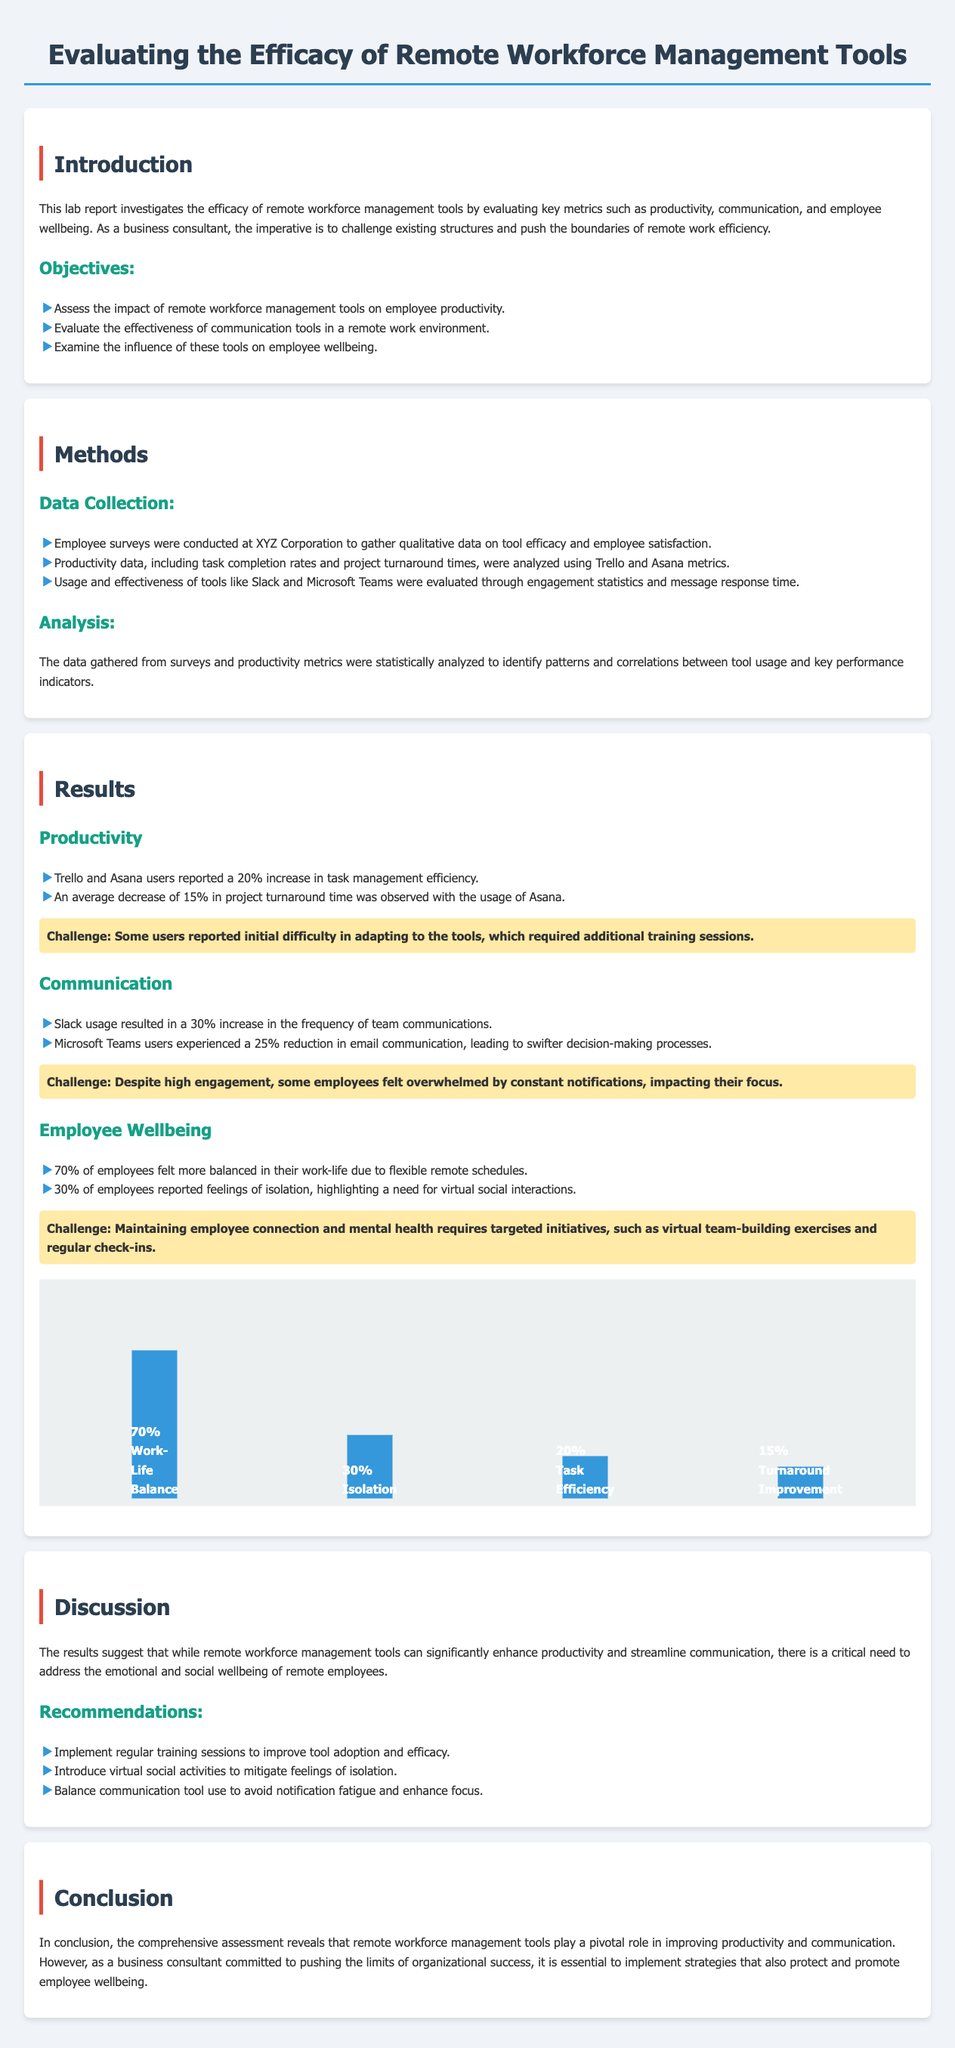what was the increase in task management efficiency reported by Trello and Asana users? The document states that Trello and Asana users reported a 20% increase in task management efficiency.
Answer: 20% what percentage of employees felt more balanced in their work-life? According to the results, 70% of employees felt more balanced in their work-life due to flexible remote schedules.
Answer: 70% which tool resulted in a 30% increase in the frequency of team communications? The results indicate that Slack usage led to a 30% increase in the frequency of team communications.
Answer: Slack what percentage of employees reported feelings of isolation? The document mentions that 30% of employees reported feelings of isolation.
Answer: 30% what is one of the key recommendations for improving tool efficacy? The report recommends implementing regular training sessions to improve tool adoption and efficacy.
Answer: Regular training sessions what was the average decrease in project turnaround time with Asana? The document notes an average decrease of 15% in project turnaround time observed with the usage of Asana.
Answer: 15% how many employees responded positively to flexible remote schedules? The findings show that 70% of employees felt more balanced in their work-life, which indicates a positive response to flexible schedules.
Answer: 70% what challenge was noted with employee engagement in communication tools? The document states that some employees felt overwhelmed by constant notifications, impacting their focus, indicating a challenge with engagement in communication tools.
Answer: Overwhelmed by notifications 